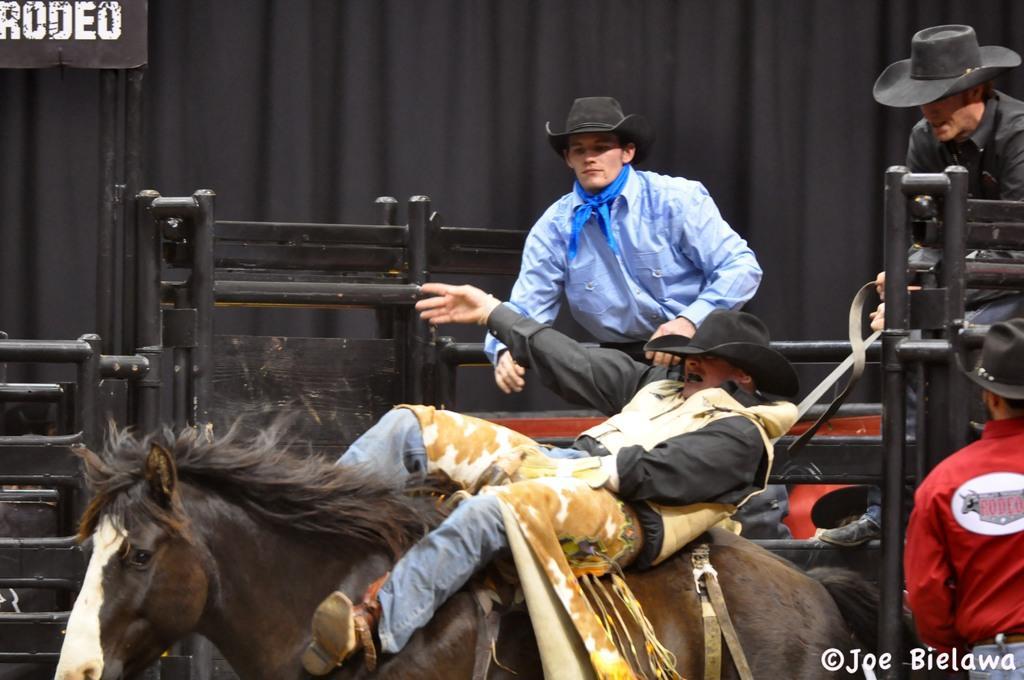Could you give a brief overview of what you see in this image? At the bottom of the image a man is riding a horse. Behind him there is fencing. Behind the fencing few people are standing and watching. At the top of the image there is a banner and cloth. 